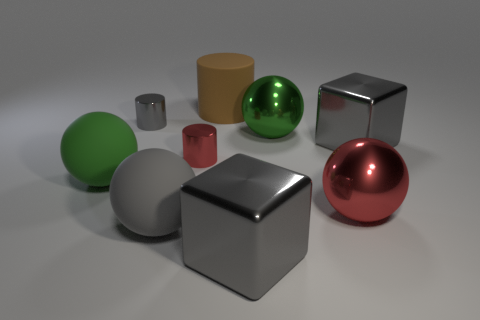How many objects are behind the large green metallic sphere and left of the large rubber cylinder?
Your answer should be very brief. 1. Is there anything else that has the same shape as the big green matte object?
Offer a terse response. Yes. There is a big cylinder; does it have the same color as the metal object that is to the left of the small red thing?
Your response must be concise. No. The tiny metallic object behind the tiny red shiny cylinder has what shape?
Your answer should be compact. Cylinder. How many other things are made of the same material as the gray cylinder?
Offer a terse response. 5. What is the material of the big cylinder?
Provide a short and direct response. Rubber. How many small things are either gray shiny objects or brown rubber cylinders?
Your answer should be compact. 1. How many brown rubber things are behind the red sphere?
Make the answer very short. 1. Is there a thing that has the same color as the big cylinder?
Provide a succinct answer. No. The brown thing that is the same size as the red ball is what shape?
Keep it short and to the point. Cylinder. 